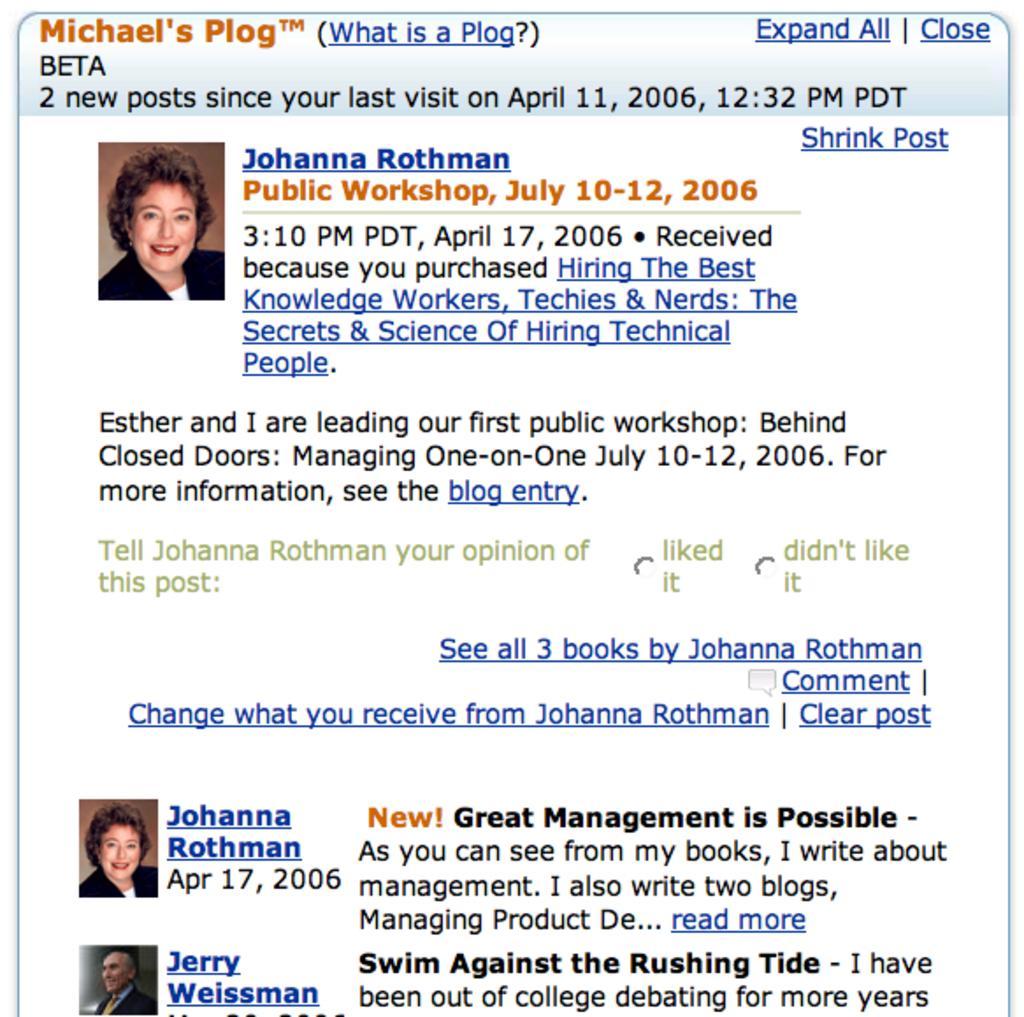Please provide a concise description of this image. It is the image taken from some website and a lot of information mentioned in the picture related to a workshop. 